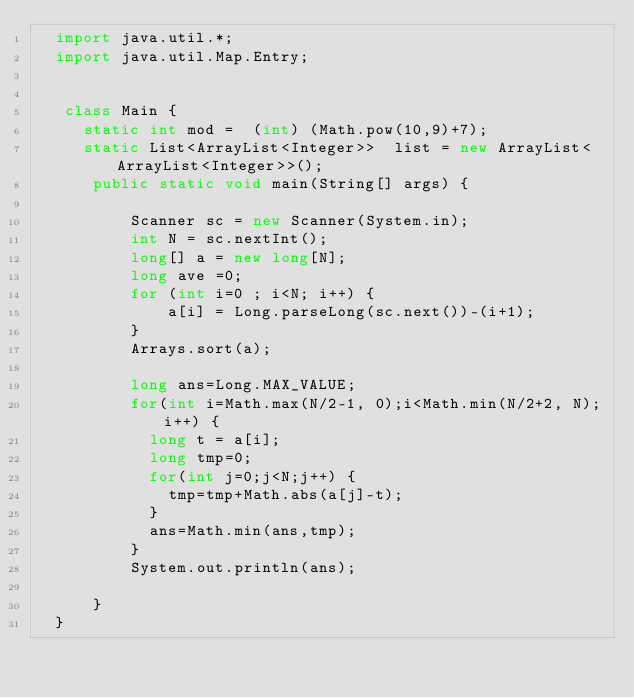Convert code to text. <code><loc_0><loc_0><loc_500><loc_500><_Java_>	import java.util.*;
	import java.util.Map.Entry;
	 
	 
	 class Main {
		 static int mod =  (int) (Math.pow(10,9)+7);
		 static List<ArrayList<Integer>>  list = new ArrayList<ArrayList<Integer>>();
	    public static void main(String[] args) {
	    	
	        Scanner sc = new Scanner(System.in);
	        int N = sc.nextInt();	
	        long[] a = new long[N];
	        long ave =0;
	        for (int i=0 ; i<N; i++) {
	            a[i] = Long.parseLong(sc.next())-(i+1);
	        }
	        Arrays.sort(a);
	        
	        long ans=Long.MAX_VALUE;
	        for(int i=Math.max(N/2-1, 0);i<Math.min(N/2+2, N);i++) {
	        	long t = a[i];
	        	long tmp=0;
	        	for(int j=0;j<N;j++) {
		        	tmp=tmp+Math.abs(a[j]-t);	        		
	        	}
	        	ans=Math.min(ans,tmp);
	        }
	        System.out.println(ans);
	        
	    }
	}</code> 